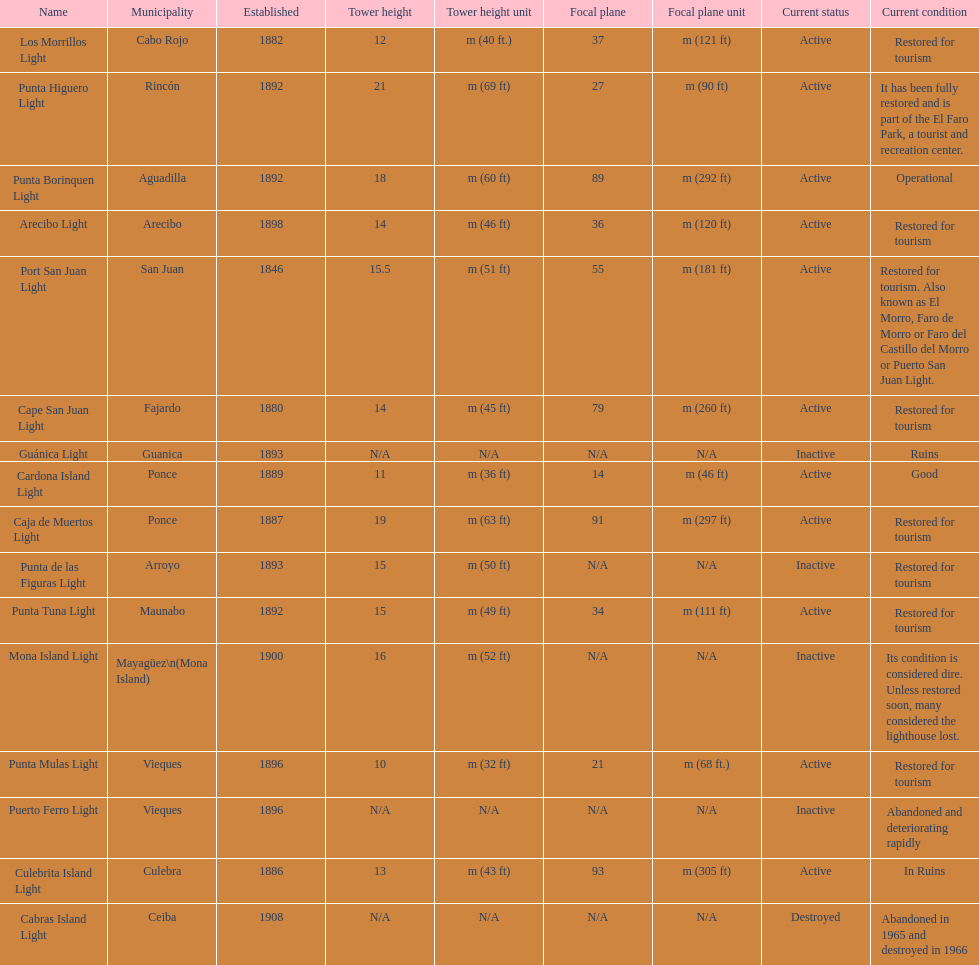Could you parse the entire table as a dict? {'header': ['Name', 'Municipality', 'Established', 'Tower height', 'Tower height unit', 'Focal plane', 'Focal plane unit', 'Current status', 'Current condition'], 'rows': [['Los Morrillos Light', 'Cabo Rojo', '1882', '12', 'm (40 ft.)', '37', 'm (121 ft)', 'Active', 'Restored for tourism'], ['Punta Higuero Light', 'Rincón', '1892', '21', 'm (69 ft)', '27', 'm (90 ft)', 'Active', 'It has been fully restored and is part of the El Faro Park, a tourist and recreation center.'], ['Punta Borinquen Light', 'Aguadilla', '1892', '18', 'm (60 ft)', '89', 'm (292 ft)', 'Active', 'Operational'], ['Arecibo Light', 'Arecibo', '1898', '14', 'm (46 ft)', '36', 'm (120 ft)', 'Active', 'Restored for tourism'], ['Port San Juan Light', 'San Juan', '1846', '15.5', 'm (51 ft)', '55', 'm (181 ft)', 'Active', 'Restored for tourism. Also known as El Morro, Faro de Morro or Faro del Castillo del Morro or Puerto San Juan Light.'], ['Cape San Juan Light', 'Fajardo', '1880', '14', 'm (45 ft)', '79', 'm (260 ft)', 'Active', 'Restored for tourism'], ['Guánica Light', 'Guanica', '1893', 'N/A', 'N/A', 'N/A', 'N/A', 'Inactive', 'Ruins'], ['Cardona Island Light', 'Ponce', '1889', '11', 'm (36 ft)', '14', 'm (46 ft)', 'Active', 'Good'], ['Caja de Muertos Light', 'Ponce', '1887', '19', 'm (63 ft)', '91', 'm (297 ft)', 'Active', 'Restored for tourism'], ['Punta de las Figuras Light', 'Arroyo', '1893', '15', 'm (50 ft)', 'N/A', 'N/A', 'Inactive', 'Restored for tourism'], ['Punta Tuna Light', 'Maunabo', '1892', '15', 'm (49 ft)', '34', 'm (111 ft)', 'Active', 'Restored for tourism'], ['Mona Island Light', 'Mayagüez\\n(Mona Island)', '1900', '16', 'm (52 ft)', 'N/A', 'N/A', 'Inactive', 'Its condition is considered dire. Unless restored soon, many considered the lighthouse lost.'], ['Punta Mulas Light', 'Vieques', '1896', '10', 'm (32 ft)', '21', 'm (68 ft.)', 'Active', 'Restored for tourism'], ['Puerto Ferro Light', 'Vieques', '1896', 'N/A', 'N/A', 'N/A', 'N/A', 'Inactive', 'Abandoned and deteriorating rapidly'], ['Culebrita Island Light', 'Culebra', '1886', '13', 'm (43 ft)', '93', 'm (305 ft)', 'Active', 'In Ruins'], ['Cabras Island Light', 'Ceiba', '1908', 'N/A', 'N/A', 'N/A', 'N/A', 'Destroyed', 'Abandoned in 1965 and destroyed in 1966']]} What is the largest tower Punta Higuero Light. 